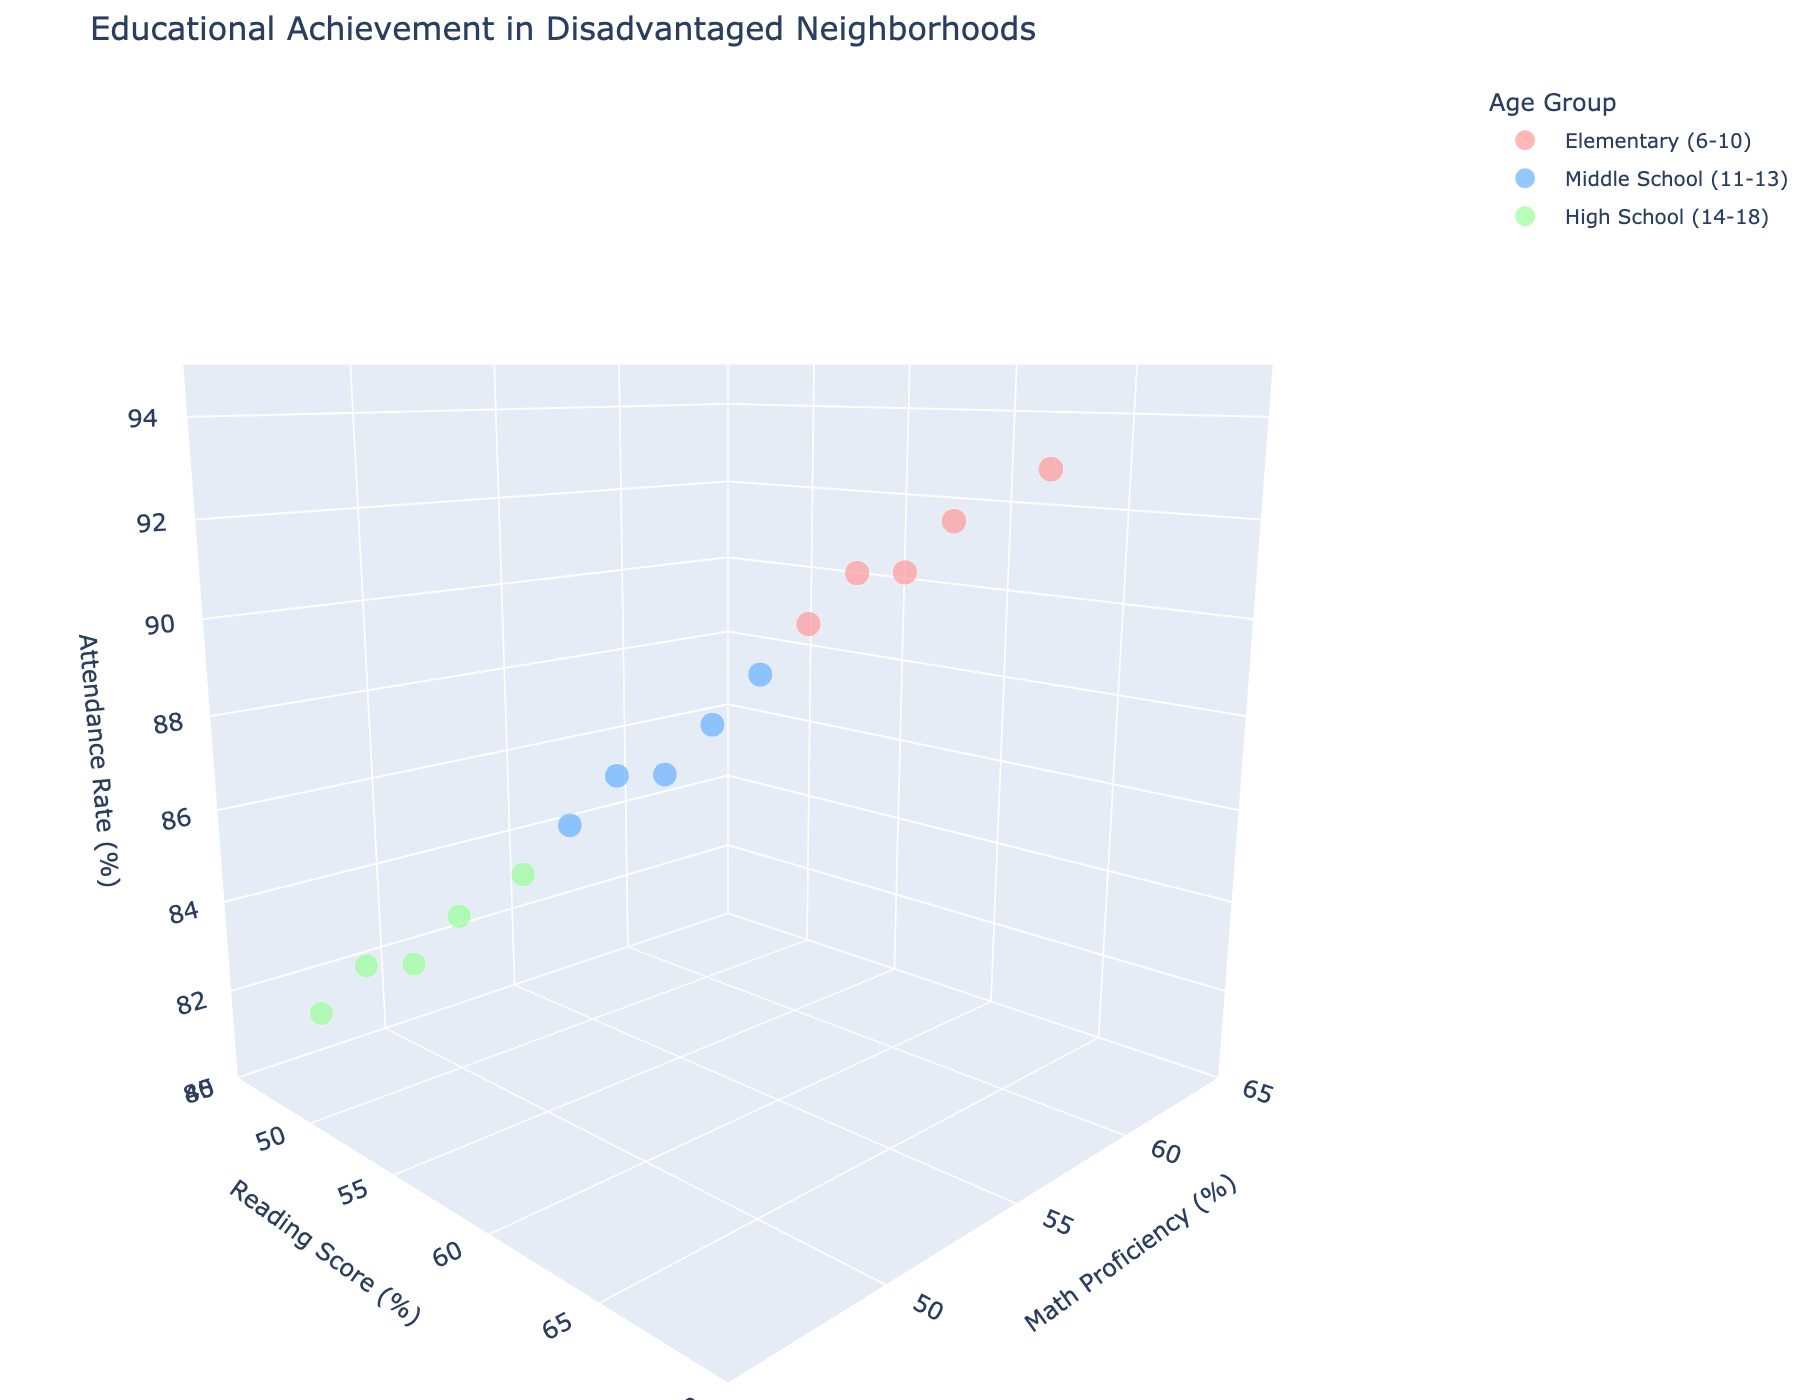What's the title of the figure? The title of the figure is positioned at the top of the plot and is meant to summarize what the plot is about.
Answer: Educational Achievement in Disadvantaged Neighborhoods How many age groups are represented in the figure? Each color represents a different age group, and there are three distinct colors present in the scatter plot.
Answer: 3 What is the range for the Attendance Rate axis? The Attendance Rate axis range is defined and it spans from 80 to 95 as per the figure settings.
Answer: 80 to 95 Which age group appears to have the highest Attendance Rates overall? By observing the z-axis (Attendance Rate) and the colors assigned to age groups, the Elementary (6-10) group consistently has higher Attendance Rates.
Answer: Elementary (6-10) For the Middle School (11-13) group, what is the approximate math proficiency range shown in the figure? By looking at the y-axis (Math Proficiency) and the points colored for Middle School (11-13), their proficiency appears to range between approximately 51% to 55%.
Answer: 51% to 55% What's the average Reading Score for the High School (14-18) group? To find the average, add the Reading Scores for High School (49, 50, 51, 52, 54) and divide by the number of records. Calculation: (49 + 50 + 51 + 52 + 54) / 5 = 256 / 5 = 51.2
Answer: 51.2 Which age group has the lowest Math Proficiency? Analyzing the y-axis and the corresponding age groups, the High School (14-18) group consistently shows the lowest Math Proficiency scores.
Answer: High School (14-18) Are there any data points with an exact Attendance Rate of 91%? If so, which age group do they belong to? Locate the points on the z-axis corresponding to 91% and then check which color/age group they belong to. The Elementary (6-10) group has data points with 91% Attendance Rate.
Answer: Elementary (6-10) Between Elementary (6-10) and Middle School (11-13) groups, which has a better average Reading Score? Calculate the average Reading Score for both, then compare. For Elementary (62, 65, 60, 63, 61), average = (62+65+60+63+61) / 5 = 62.2. For Middle School (57, 59, 55, 58, 56), average = (57+59+55+58+56) / 5 = 57.
Answer: Elementary (6-10) Do any age groups have overlapping ranges in Reading Scores and Math Proficiency? By comparing the x-axis (Reading Score) and y-axis (Math Proficiency) ranges for all age groups, Middle School, and Elementary show some overlapping ranges in both parameters.
Answer: Yes 